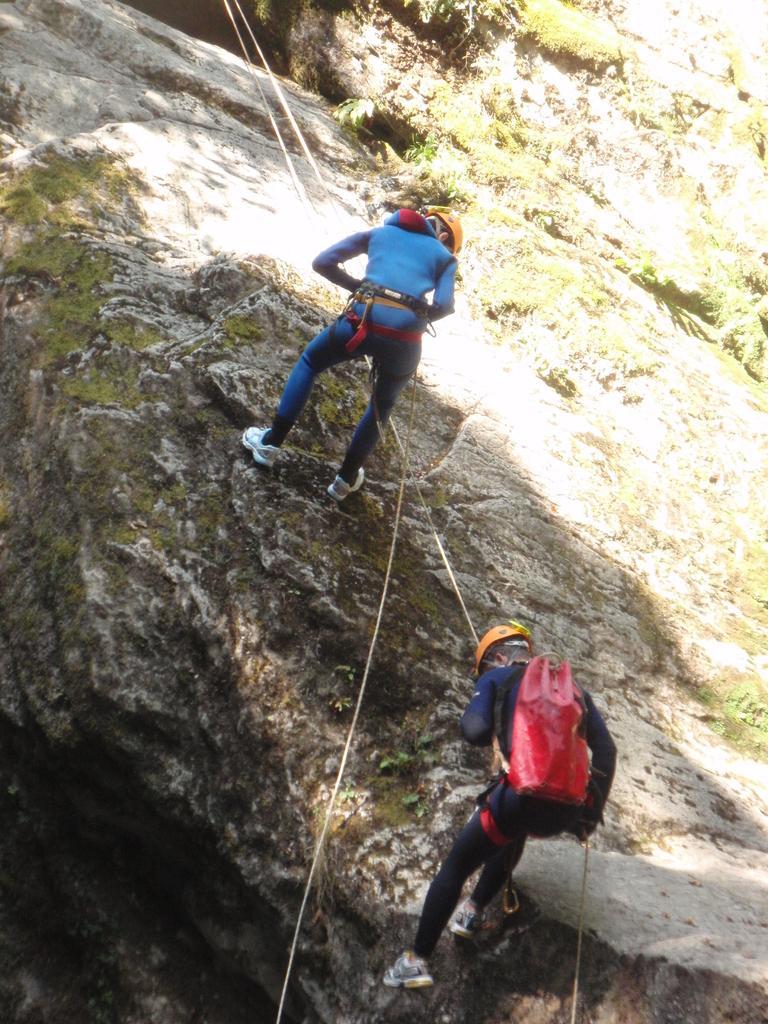How would you summarize this image in a sentence or two? In this image there are people doing treeking on the rock mountains. 